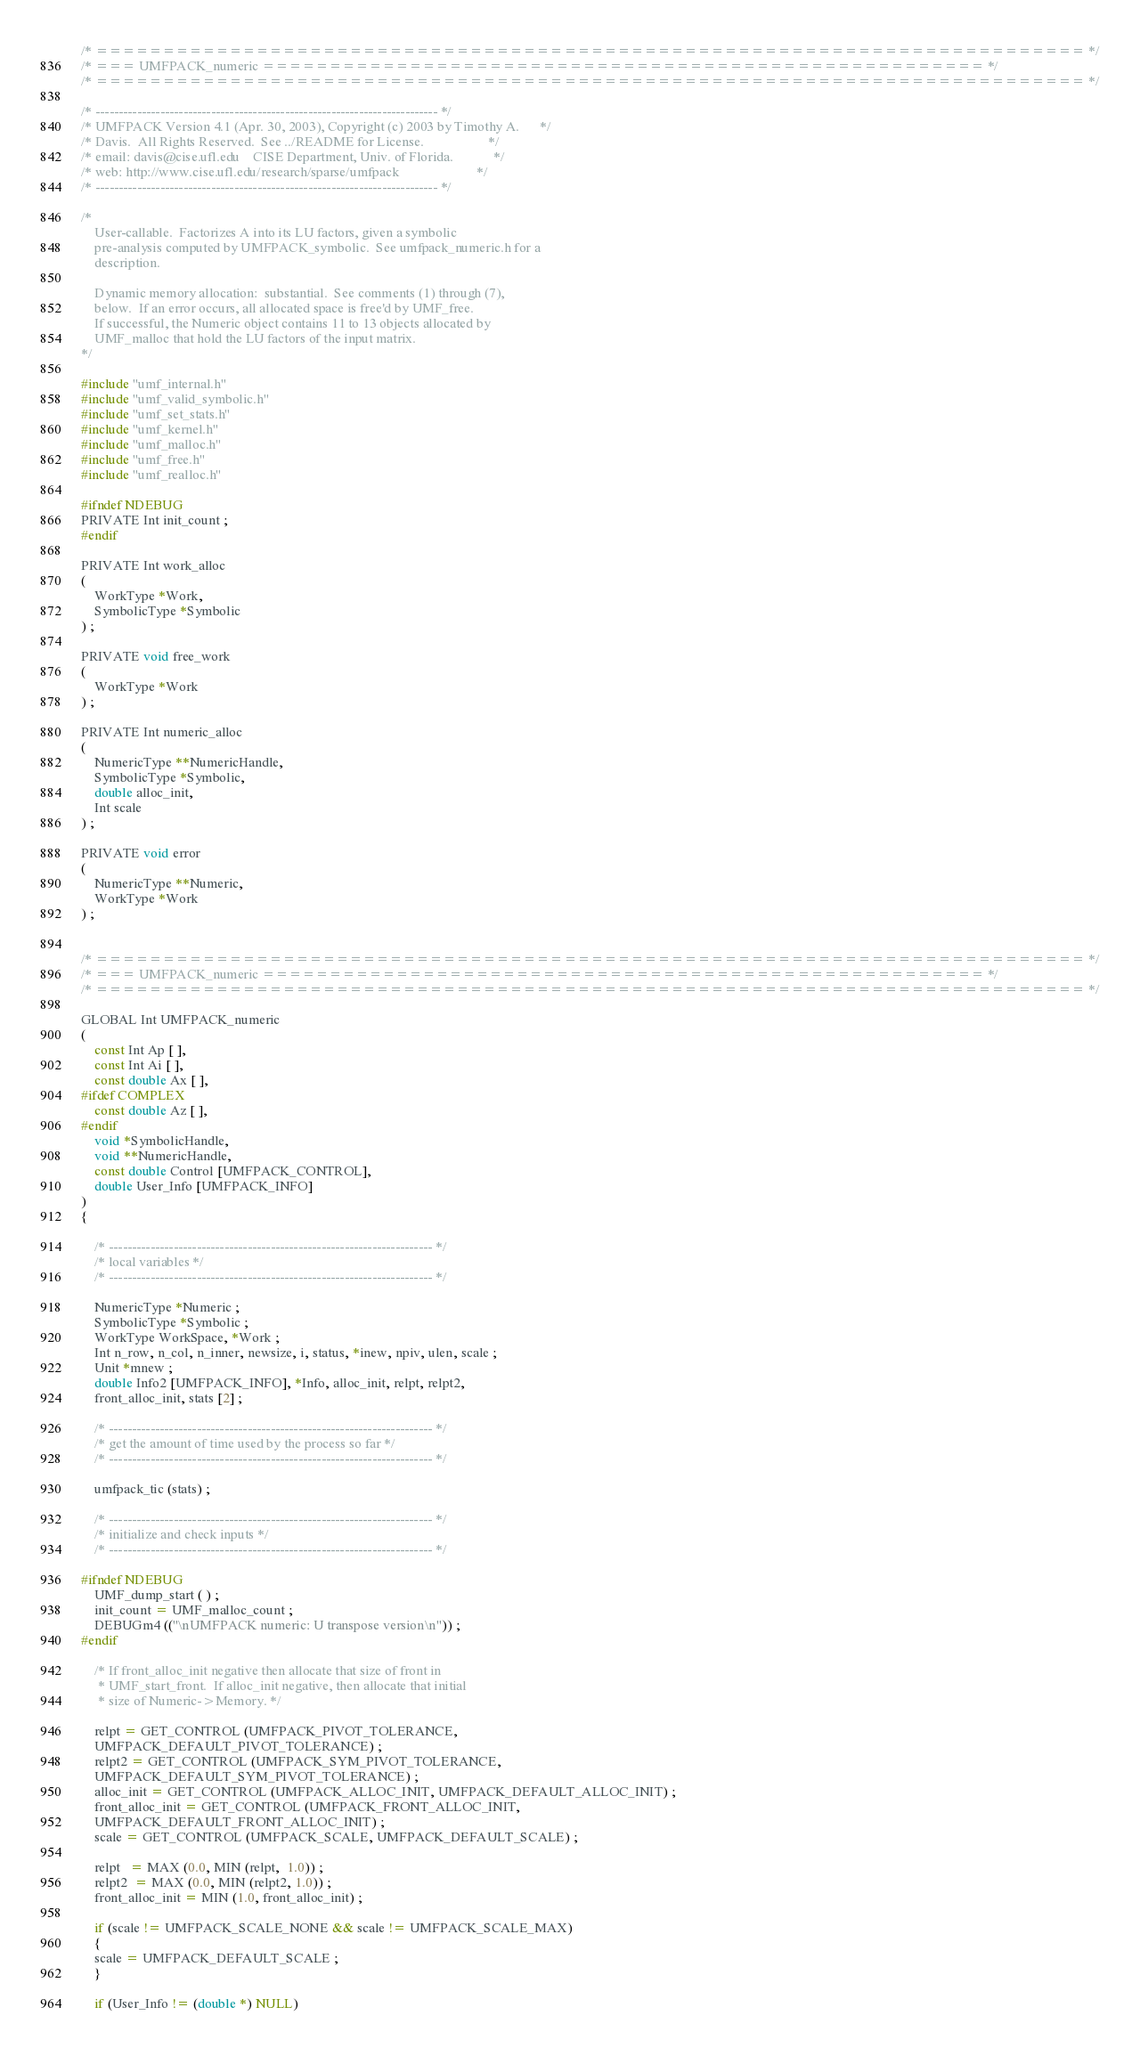Convert code to text. <code><loc_0><loc_0><loc_500><loc_500><_C_>/* ========================================================================== */
/* === UMFPACK_numeric ====================================================== */
/* ========================================================================== */

/* -------------------------------------------------------------------------- */
/* UMFPACK Version 4.1 (Apr. 30, 2003), Copyright (c) 2003 by Timothy A.      */
/* Davis.  All Rights Reserved.  See ../README for License.                   */
/* email: davis@cise.ufl.edu    CISE Department, Univ. of Florida.            */
/* web: http://www.cise.ufl.edu/research/sparse/umfpack                       */
/* -------------------------------------------------------------------------- */

/*
    User-callable.  Factorizes A into its LU factors, given a symbolic
    pre-analysis computed by UMFPACK_symbolic.  See umfpack_numeric.h for a
    description.

    Dynamic memory allocation:  substantial.  See comments (1) through (7),
    below.  If an error occurs, all allocated space is free'd by UMF_free.
    If successful, the Numeric object contains 11 to 13 objects allocated by
    UMF_malloc that hold the LU factors of the input matrix.
*/

#include "umf_internal.h"
#include "umf_valid_symbolic.h"
#include "umf_set_stats.h"
#include "umf_kernel.h"
#include "umf_malloc.h"
#include "umf_free.h"
#include "umf_realloc.h"

#ifndef NDEBUG
PRIVATE Int init_count ;
#endif

PRIVATE Int work_alloc
(
    WorkType *Work,
    SymbolicType *Symbolic
) ;

PRIVATE void free_work
(
    WorkType *Work
) ;

PRIVATE Int numeric_alloc
(
    NumericType **NumericHandle,
    SymbolicType *Symbolic,
    double alloc_init,
    Int scale
) ;

PRIVATE void error
(
    NumericType **Numeric,
    WorkType *Work
) ;


/* ========================================================================== */
/* === UMFPACK_numeric ====================================================== */
/* ========================================================================== */

GLOBAL Int UMFPACK_numeric
(
    const Int Ap [ ],
    const Int Ai [ ],
    const double Ax [ ],
#ifdef COMPLEX
    const double Az [ ],
#endif
    void *SymbolicHandle,
    void **NumericHandle,
    const double Control [UMFPACK_CONTROL],
    double User_Info [UMFPACK_INFO]
)
{

    /* ---------------------------------------------------------------------- */
    /* local variables */
    /* ---------------------------------------------------------------------- */

    NumericType *Numeric ;
    SymbolicType *Symbolic ;
    WorkType WorkSpace, *Work ;
    Int n_row, n_col, n_inner, newsize, i, status, *inew, npiv, ulen, scale ;
    Unit *mnew ;
    double Info2 [UMFPACK_INFO], *Info, alloc_init, relpt, relpt2,
	front_alloc_init, stats [2] ;

    /* ---------------------------------------------------------------------- */
    /* get the amount of time used by the process so far */
    /* ---------------------------------------------------------------------- */

    umfpack_tic (stats) ;

    /* ---------------------------------------------------------------------- */
    /* initialize and check inputs */
    /* ---------------------------------------------------------------------- */

#ifndef NDEBUG
    UMF_dump_start ( ) ;
    init_count = UMF_malloc_count ;
    DEBUGm4 (("\nUMFPACK numeric: U transpose version\n")) ;
#endif

    /* If front_alloc_init negative then allocate that size of front in
     * UMF_start_front.  If alloc_init negative, then allocate that initial
     * size of Numeric->Memory. */

    relpt = GET_CONTROL (UMFPACK_PIVOT_TOLERANCE,
	UMFPACK_DEFAULT_PIVOT_TOLERANCE) ;
    relpt2 = GET_CONTROL (UMFPACK_SYM_PIVOT_TOLERANCE,
	UMFPACK_DEFAULT_SYM_PIVOT_TOLERANCE) ;
    alloc_init = GET_CONTROL (UMFPACK_ALLOC_INIT, UMFPACK_DEFAULT_ALLOC_INIT) ;
    front_alloc_init = GET_CONTROL (UMFPACK_FRONT_ALLOC_INIT,
	UMFPACK_DEFAULT_FRONT_ALLOC_INIT) ;
    scale = GET_CONTROL (UMFPACK_SCALE, UMFPACK_DEFAULT_SCALE) ;

    relpt   = MAX (0.0, MIN (relpt,  1.0)) ;
    relpt2  = MAX (0.0, MIN (relpt2, 1.0)) ;
    front_alloc_init = MIN (1.0, front_alloc_init) ;

    if (scale != UMFPACK_SCALE_NONE && scale != UMFPACK_SCALE_MAX)
    {
	scale = UMFPACK_DEFAULT_SCALE ;
    }

    if (User_Info != (double *) NULL)</code> 